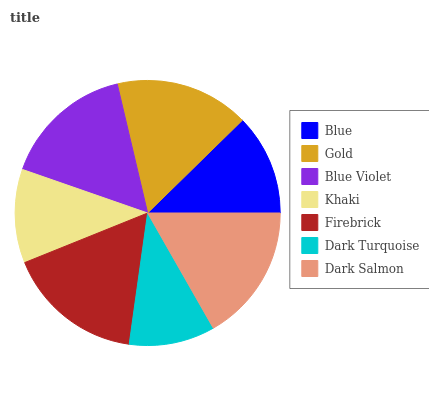Is Dark Turquoise the minimum?
Answer yes or no. Yes. Is Dark Salmon the maximum?
Answer yes or no. Yes. Is Gold the minimum?
Answer yes or no. No. Is Gold the maximum?
Answer yes or no. No. Is Gold greater than Blue?
Answer yes or no. Yes. Is Blue less than Gold?
Answer yes or no. Yes. Is Blue greater than Gold?
Answer yes or no. No. Is Gold less than Blue?
Answer yes or no. No. Is Blue Violet the high median?
Answer yes or no. Yes. Is Blue Violet the low median?
Answer yes or no. Yes. Is Dark Salmon the high median?
Answer yes or no. No. Is Gold the low median?
Answer yes or no. No. 